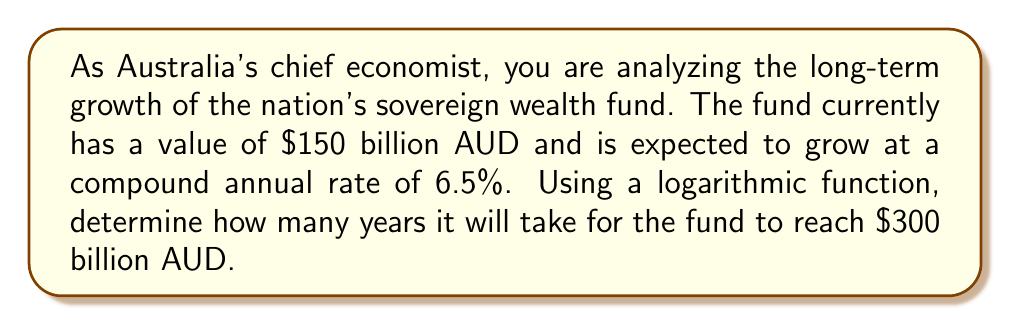Help me with this question. To solve this problem, we'll use the compound interest formula and apply logarithms to isolate the time variable. Let's break it down step-by-step:

1) The compound interest formula is:
   $$ A = P(1 + r)^t $$
   Where:
   $A$ is the final amount
   $P$ is the principal (initial investment)
   $r$ is the annual interest rate (as a decimal)
   $t$ is the time in years

2) We know:
   $P = 150$ billion AUD
   $A = 300$ billion AUD (target amount)
   $r = 0.065$ (6.5% as a decimal)

3) Let's substitute these values into the formula:
   $$ 300 = 150(1 + 0.065)^t $$

4) Divide both sides by 150:
   $$ 2 = (1.065)^t $$

5) Now, we can apply the natural logarithm to both sides:
   $$ \ln(2) = \ln((1.065)^t) $$

6) Using the logarithm property $\ln(a^b) = b\ln(a)$, we get:
   $$ \ln(2) = t \ln(1.065) $$

7) Solve for $t$ by dividing both sides by $\ln(1.065)$:
   $$ t = \frac{\ln(2)}{\ln(1.065)} $$

8) Calculate the result:
   $$ t \approx 10.99 \text{ years} $$
Answer: It will take approximately 11 years for Australia's sovereign wealth fund to grow from $150 billion AUD to $300 billion AUD at a 6.5% compound annual growth rate. 